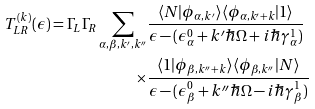<formula> <loc_0><loc_0><loc_500><loc_500>T ^ { ( k ) } _ { L R } ( \epsilon ) = \Gamma _ { L } \Gamma _ { R } \sum _ { \alpha , \beta , k ^ { \prime } , k ^ { \prime \prime } } & \frac { \langle N | \phi _ { \alpha , k ^ { \prime } } \rangle \langle \phi _ { \alpha , k ^ { \prime } + k } | 1 \rangle } { \epsilon - ( \epsilon _ { \alpha } ^ { 0 } + k ^ { \prime } \hbar { \Omega } + i \hbar { \gamma } _ { \alpha } ^ { 1 } ) } \\ \times & \frac { \langle 1 | \phi _ { \beta , k ^ { \prime \prime } + k } \rangle \langle \phi _ { \beta , k ^ { \prime \prime } } | N \rangle } { \epsilon - ( \epsilon _ { \beta } ^ { 0 } + k ^ { \prime \prime } \hbar { \Omega } - i \hbar { \gamma } _ { \beta } ^ { 1 } ) }</formula> 